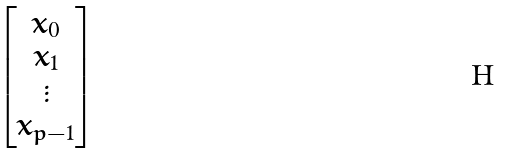<formula> <loc_0><loc_0><loc_500><loc_500>\begin{bmatrix} x _ { 0 } \\ x _ { 1 } \\ \vdots \\ x _ { p - 1 } \end{bmatrix}</formula> 